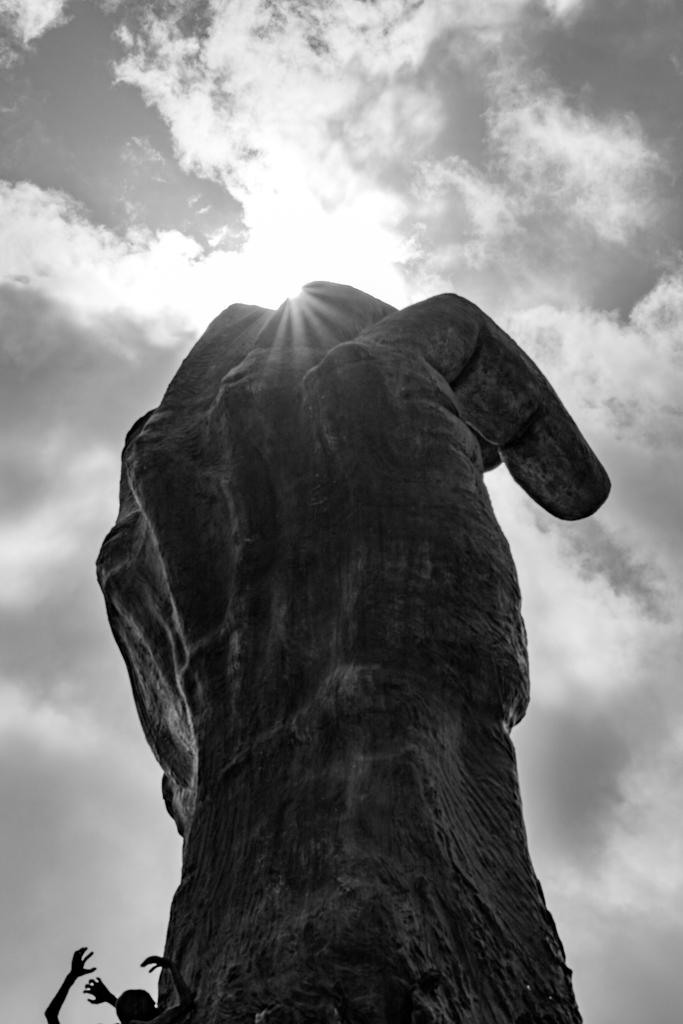What is the color scheme of the image? The image is black and white. What is the main subject of the image? There is a statue of a hand in the image. What can be seen in the background of the image? The sky with clouds is visible in the background of the image. What else is present at the bottom of the image? A person and hands are present at the bottom of the image. How many hens are visible in the image? There are no hens present in the image. What type of trouble is the person experiencing in the image? There is no indication of trouble in the image; it features a statue of a hand, the sky with clouds, and a person with hands at the bottom. 